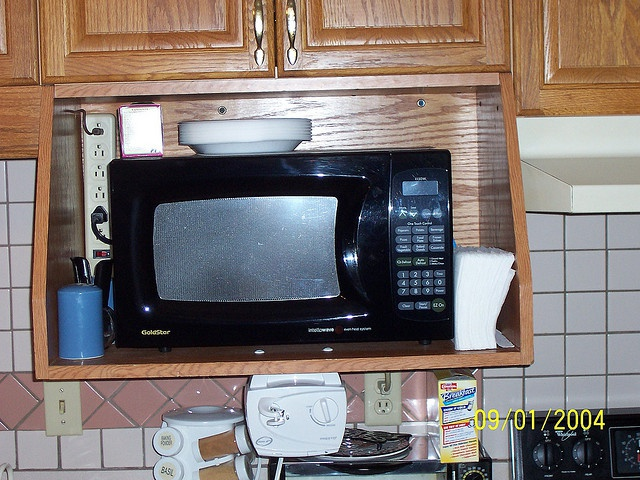Describe the objects in this image and their specific colors. I can see microwave in gray and black tones and oven in gray, black, and blue tones in this image. 